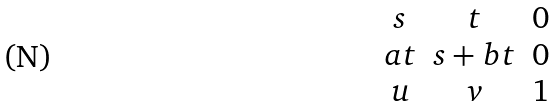Convert formula to latex. <formula><loc_0><loc_0><loc_500><loc_500>\begin{matrix} s & t & 0 \\ a t & s + b t & 0 \\ u & v & 1 \end{matrix}</formula> 